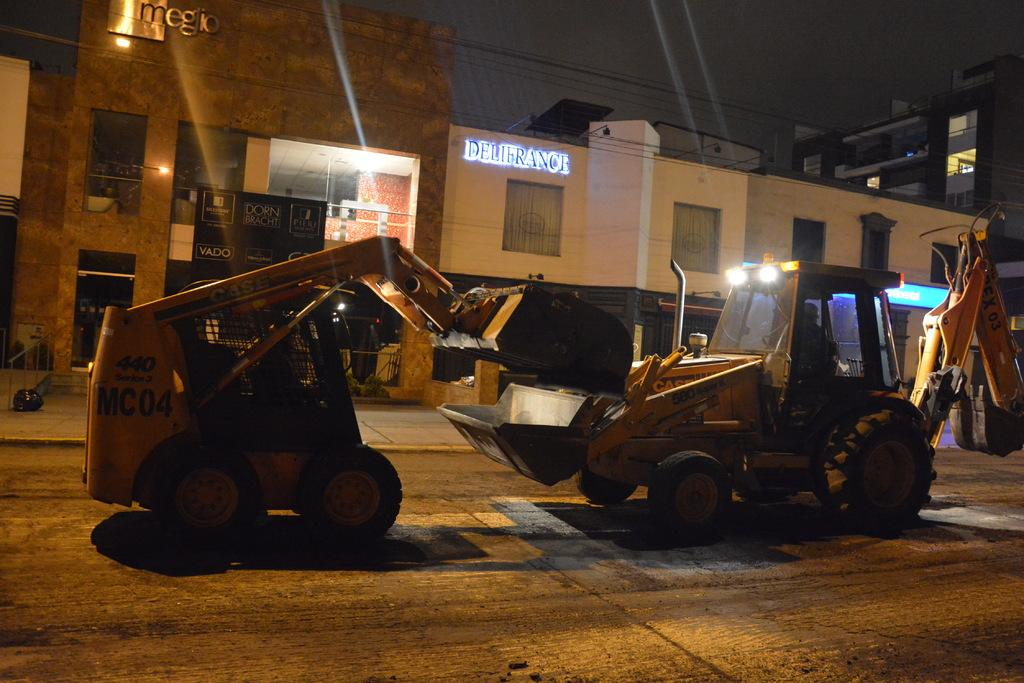<image>
Write a terse but informative summary of the picture. A piece of heavy equipment marked MC 04 is working in conjunction with another piece of heavy equipment. 